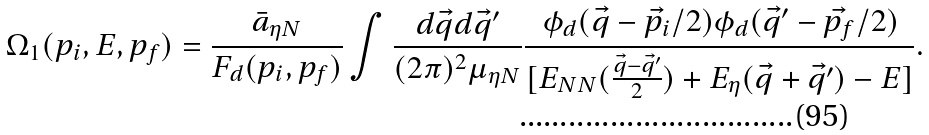Convert formula to latex. <formula><loc_0><loc_0><loc_500><loc_500>\Omega _ { 1 } ( p _ { i } , E , p _ { f } ) = \frac { \bar { a } _ { \eta N } } { F _ { d } ( p _ { i } , p _ { f } ) } \int \frac { d \vec { q } d \vec { q } ^ { \prime } } { ( 2 \pi ) ^ { 2 } \mu _ { \eta N } } \frac { \phi _ { d } ( \vec { q } - \vec { p _ { i } } / 2 ) \phi _ { d } ( \vec { q } ^ { \prime } - \vec { p _ { f } } / 2 ) } { [ E _ { N N } ( \frac { \vec { q } - \vec { q } ^ { \prime } } { 2 } ) + E _ { \eta } ( \vec { q } + \vec { q } ^ { \prime } ) - E ] } .</formula> 